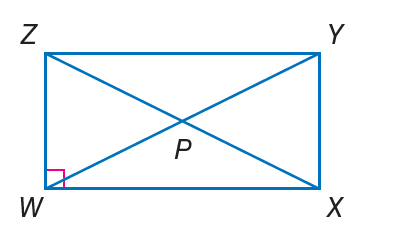Answer the mathemtical geometry problem and directly provide the correct option letter.
Question: Quadrilateral W X Y Z is a rectangle. If Z Y = 2 x + 3 and W X = x + 4, find W X.
Choices: A: 2 B: 5 C: 7 D: 10 B 